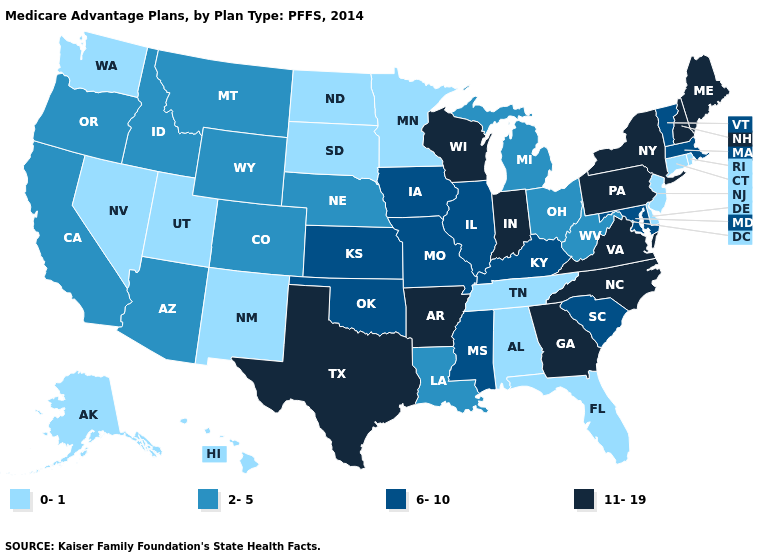Does Connecticut have the lowest value in the USA?
Answer briefly. Yes. Is the legend a continuous bar?
Be succinct. No. What is the value of Pennsylvania?
Keep it brief. 11-19. Name the states that have a value in the range 11-19?
Short answer required. Arkansas, Georgia, Indiana, Maine, North Carolina, New Hampshire, New York, Pennsylvania, Texas, Virginia, Wisconsin. Does Utah have the lowest value in the USA?
Short answer required. Yes. Name the states that have a value in the range 11-19?
Short answer required. Arkansas, Georgia, Indiana, Maine, North Carolina, New Hampshire, New York, Pennsylvania, Texas, Virginia, Wisconsin. Does North Dakota have the lowest value in the MidWest?
Concise answer only. Yes. What is the lowest value in the USA?
Short answer required. 0-1. What is the highest value in the West ?
Give a very brief answer. 2-5. Is the legend a continuous bar?
Answer briefly. No. Among the states that border Michigan , which have the highest value?
Be succinct. Indiana, Wisconsin. Does New Jersey have the highest value in the Northeast?
Quick response, please. No. Among the states that border Vermont , which have the highest value?
Be succinct. New Hampshire, New York. Does the map have missing data?
Keep it brief. No. Does the map have missing data?
Keep it brief. No. 